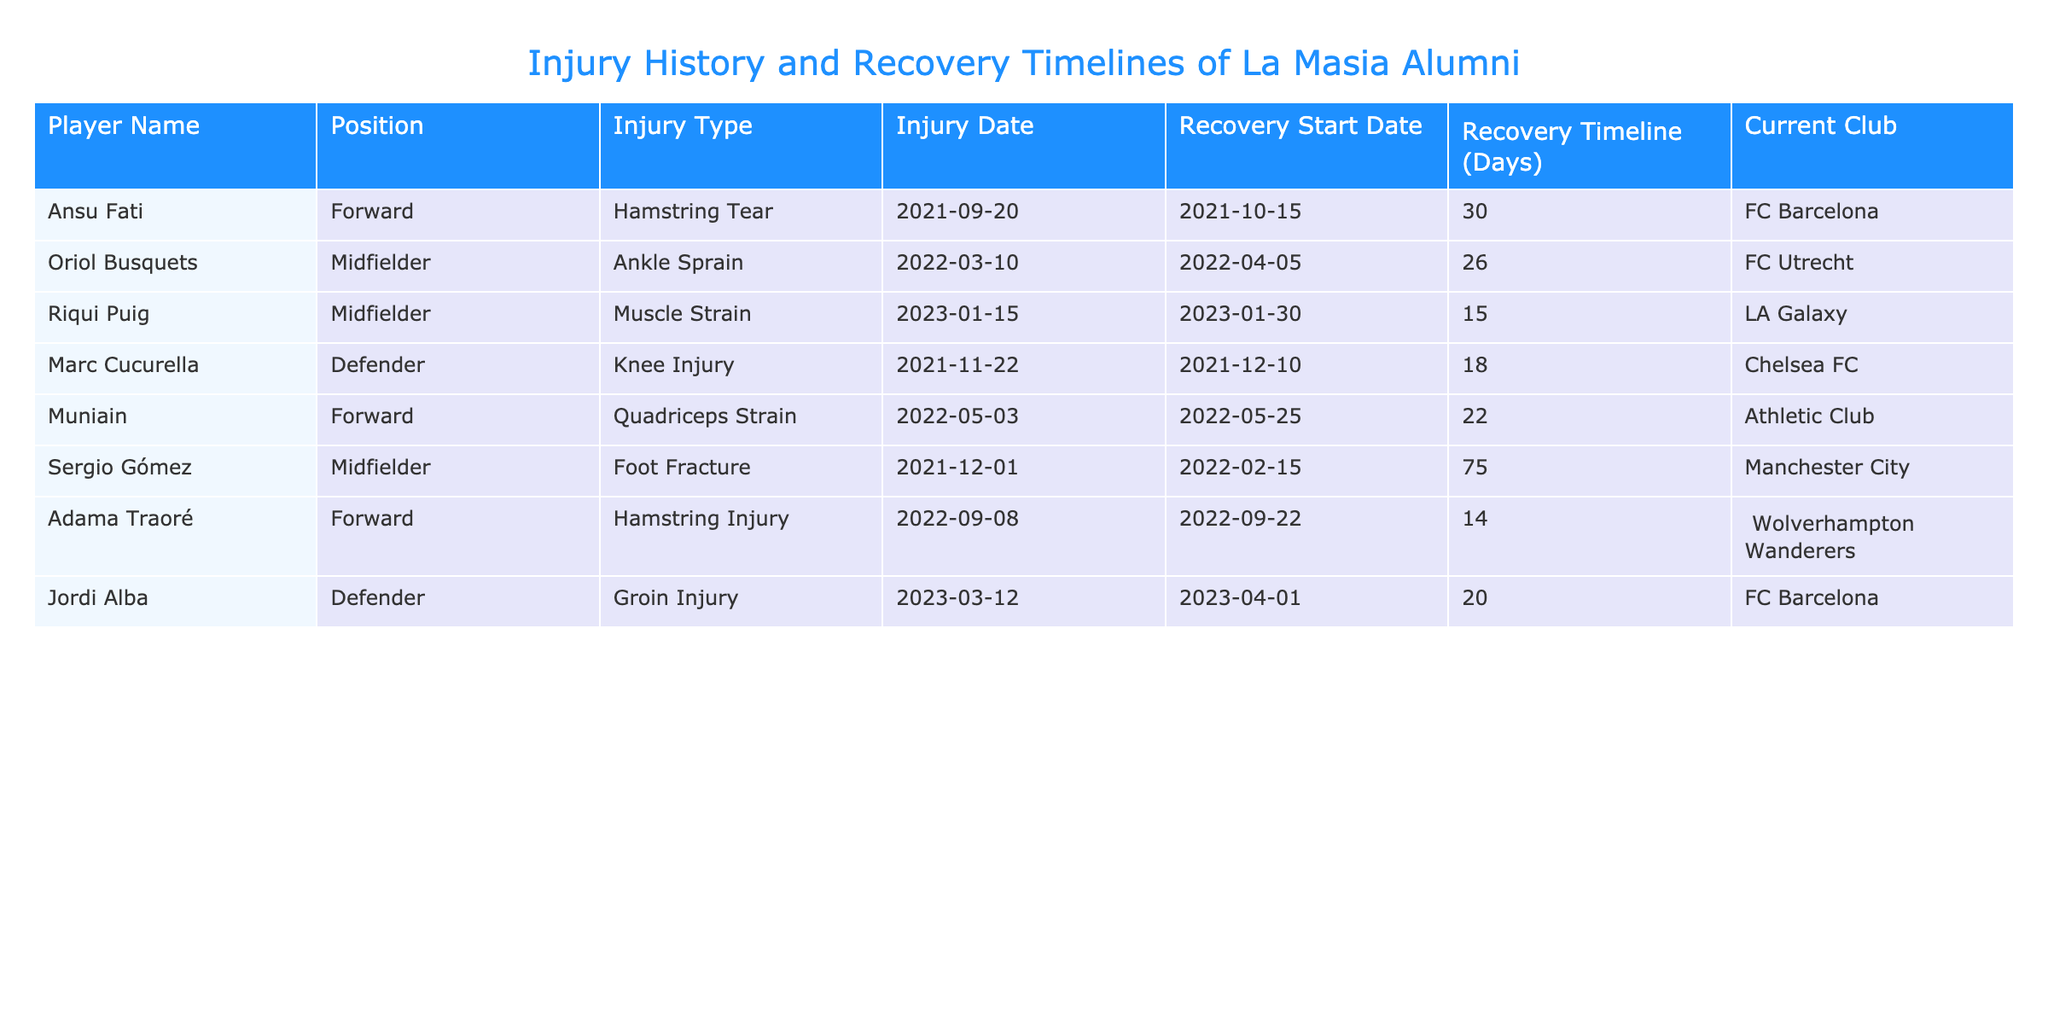What injury type did Ansu Fati suffer? Ansu Fati's injury type is indicated in the table under the "Injury Type" column corresponding to his name in the "Player Name" column. It states "Hamstring Tear".
Answer: Hamstring Tear Which player had the longest recovery timeline? To determine the longest recovery timeline, we compare the values in the "Recovery Timeline (Days)" column. Sergio Gómez has the highest number at 75 days.
Answer: Sergio Gómez How many players suffered from hamstring injuries? We can find the number of players with hamstring injuries by searching the "Injury Type" column for instances of "Hamstring". There are two players listed: Ansu Fati and Adama Traoré.
Answer: 2 What is the average recovery time for injuries listed in the table? We calculate the average by summing the recovery timelines: 30 + 26 + 15 + 18 + 22 + 75 + 14 + 20 = 250 days. There are 8 players, so we divide 250 by 8, which equals 31.25.
Answer: 31.25 days Did any player have a recovery timeline less than 20 days? We check the "Recovery Timeline (Days)" column for any values less than 20. Both Adama Traoré (14 days) and Riqui Puig (15 days) are under 20 days, so the answer is yes.
Answer: Yes Which player recovered from an ankle injury and what was their recovery timeline? We look in the table for the "Injury Type" column for "Ankle Sprain", which only applies to Oriol Busquets. His recovery timeline is 26 days.
Answer: Oriol Busquets, 26 days Did any player from FC Barcelona have a recovery timeline greater than 30 days? The players listed from FC Barcelona are Ansu Fati and Jordi Alba. Ansu Fati has a recovery timeline of 30 days, and Jordi Alba has 20 days. Neither exceeds 30 days, hence the answer is no.
Answer: No Who was injured last in the table, and what was their injury type? The players are listed chronologically by injury date, with the most recent being Jordi Alba on 2023-03-12. His injury type is "Groin Injury".
Answer: Jordi Alba, Groin Injury 